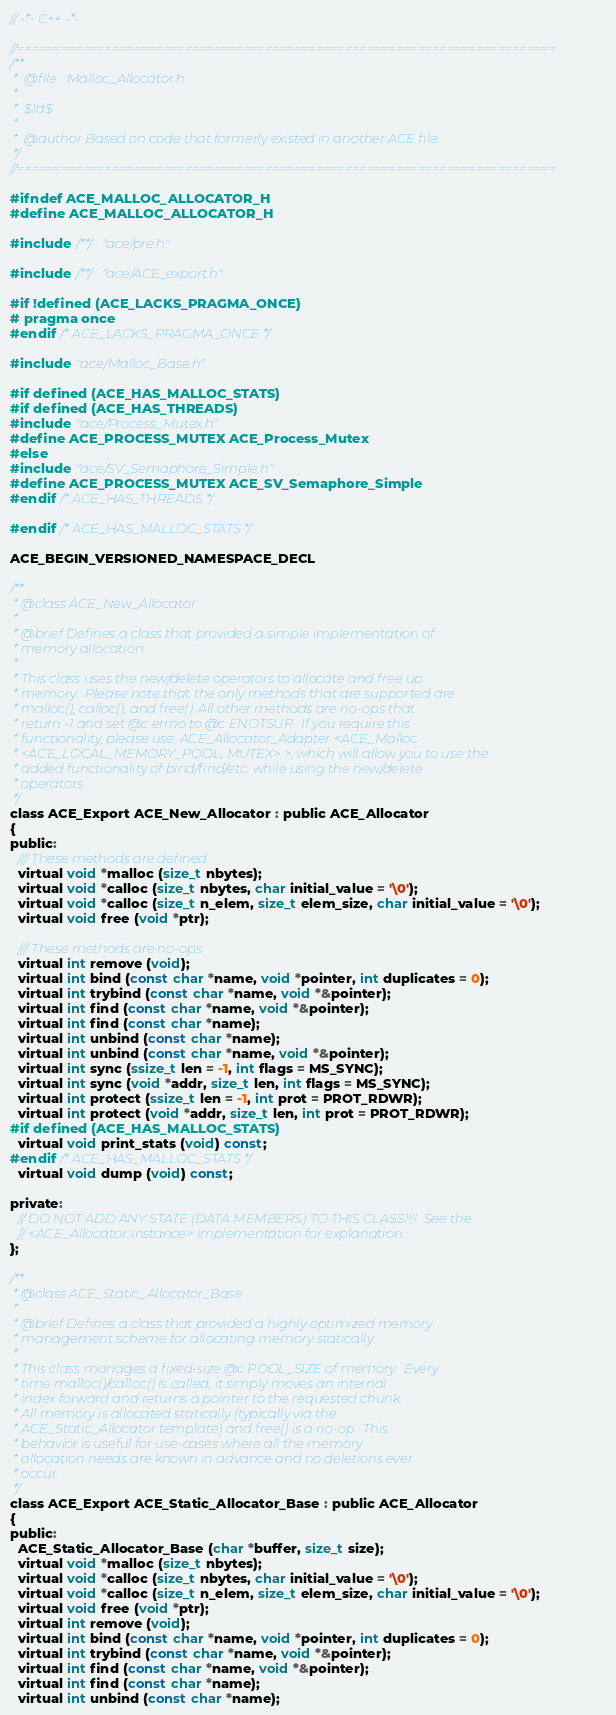<code> <loc_0><loc_0><loc_500><loc_500><_C_>// -*- C++ -*-

//==========================================================================
/**
 *  @file   Malloc_Allocator.h
 *
 *  $Id$
 *
 *  @author Based on code that formerly existed in another ACE file.
 */
//==========================================================================

#ifndef ACE_MALLOC_ALLOCATOR_H
#define ACE_MALLOC_ALLOCATOR_H

#include /**/ "ace/pre.h"

#include /**/ "ace/ACE_export.h"

#if !defined (ACE_LACKS_PRAGMA_ONCE)
# pragma once
#endif /* ACE_LACKS_PRAGMA_ONCE */

#include "ace/Malloc_Base.h"

#if defined (ACE_HAS_MALLOC_STATS)
#if defined (ACE_HAS_THREADS)
#include "ace/Process_Mutex.h"
#define ACE_PROCESS_MUTEX ACE_Process_Mutex
#else
#include "ace/SV_Semaphore_Simple.h"
#define ACE_PROCESS_MUTEX ACE_SV_Semaphore_Simple
#endif /* ACE_HAS_THREADS */

#endif /* ACE_HAS_MALLOC_STATS */

ACE_BEGIN_VERSIONED_NAMESPACE_DECL

/**
 * @class ACE_New_Allocator
 *
 * @brief Defines a class that provided a simple implementation of
 * memory allocation.
 *
 * This class uses the new/delete operators to allocate and free up
 * memory.  Please note that the only methods that are supported are
 * malloc(), calloc(), and free(). All other methods are no-ops that
 * return -1 and set @c errno to @c ENOTSUP.  If you require this
 * functionality, please use: ACE_Allocator_Adapter <ACE_Malloc
 * <ACE_LOCAL_MEMORY_POOL, MUTEX> >, which will allow you to use the
 * added functionality of bind/find/etc. while using the new/delete
 * operators.
 */
class ACE_Export ACE_New_Allocator : public ACE_Allocator
{
public:
  /// These methods are defined.
  virtual void *malloc (size_t nbytes);
  virtual void *calloc (size_t nbytes, char initial_value = '\0');
  virtual void *calloc (size_t n_elem, size_t elem_size, char initial_value = '\0');
  virtual void free (void *ptr);

  /// These methods are no-ops.
  virtual int remove (void);
  virtual int bind (const char *name, void *pointer, int duplicates = 0);
  virtual int trybind (const char *name, void *&pointer);
  virtual int find (const char *name, void *&pointer);
  virtual int find (const char *name);
  virtual int unbind (const char *name);
  virtual int unbind (const char *name, void *&pointer);
  virtual int sync (ssize_t len = -1, int flags = MS_SYNC);
  virtual int sync (void *addr, size_t len, int flags = MS_SYNC);
  virtual int protect (ssize_t len = -1, int prot = PROT_RDWR);
  virtual int protect (void *addr, size_t len, int prot = PROT_RDWR);
#if defined (ACE_HAS_MALLOC_STATS)
  virtual void print_stats (void) const;
#endif /* ACE_HAS_MALLOC_STATS */
  virtual void dump (void) const;

private:
  // DO NOT ADD ANY STATE (DATA MEMBERS) TO THIS CLASS!!!!  See the
  // <ACE_Allocator::instance> implementation for explanation.
};

/**
 * @class ACE_Static_Allocator_Base
 *
 * @brief Defines a class that provided a highly optimized memory
 * management scheme for allocating memory statically.
 *
 * This class manages a fixed-size @c POOL_SIZE of memory.  Every
 * time malloc()/calloc() is called, it simply moves an internal
 * index forward and returns a pointer to the requested chunk.
 * All memory is allocated statically (typically via the
 * ACE_Static_Allocator template) and free() is a no-op.  This
 * behavior is useful for use-cases where all the memory
 * allocation needs are known in advance and no deletions ever
 * occur.
 */
class ACE_Export ACE_Static_Allocator_Base : public ACE_Allocator
{
public:
  ACE_Static_Allocator_Base (char *buffer, size_t size);
  virtual void *malloc (size_t nbytes);
  virtual void *calloc (size_t nbytes, char initial_value = '\0');
  virtual void *calloc (size_t n_elem, size_t elem_size, char initial_value = '\0');
  virtual void free (void *ptr);
  virtual int remove (void);
  virtual int bind (const char *name, void *pointer, int duplicates = 0);
  virtual int trybind (const char *name, void *&pointer);
  virtual int find (const char *name, void *&pointer);
  virtual int find (const char *name);
  virtual int unbind (const char *name);</code> 